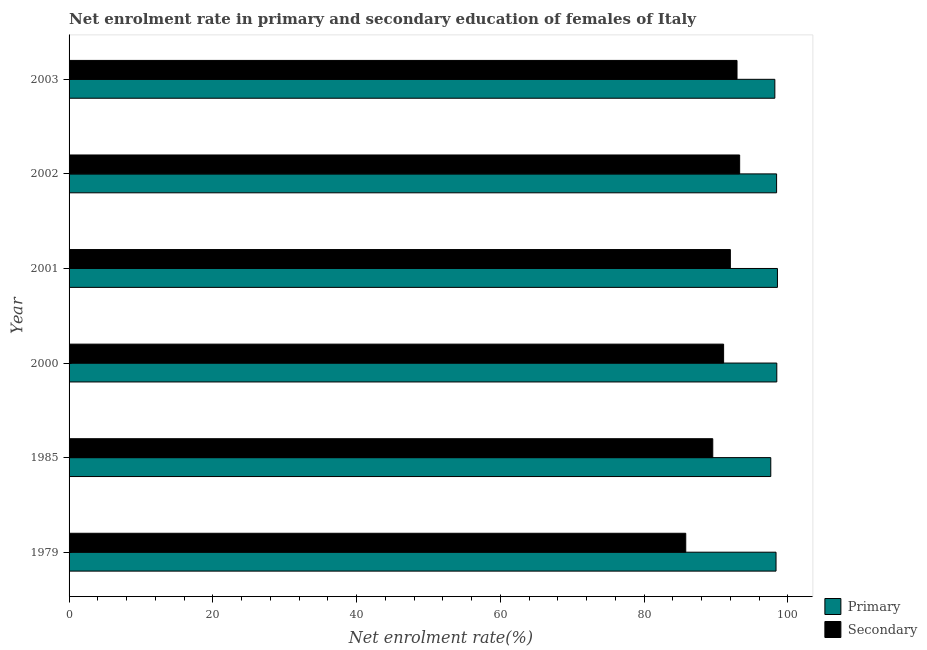How many groups of bars are there?
Your response must be concise. 6. Are the number of bars per tick equal to the number of legend labels?
Provide a succinct answer. Yes. Are the number of bars on each tick of the Y-axis equal?
Make the answer very short. Yes. What is the label of the 6th group of bars from the top?
Offer a terse response. 1979. What is the enrollment rate in primary education in 2001?
Offer a very short reply. 98.56. Across all years, what is the maximum enrollment rate in secondary education?
Provide a succinct answer. 93.3. Across all years, what is the minimum enrollment rate in primary education?
Your answer should be compact. 97.63. What is the total enrollment rate in secondary education in the graph?
Your response must be concise. 544.66. What is the difference between the enrollment rate in secondary education in 1985 and that in 2000?
Your answer should be compact. -1.51. What is the difference between the enrollment rate in primary education in 2000 and the enrollment rate in secondary education in 2002?
Provide a short and direct response. 5.17. What is the average enrollment rate in secondary education per year?
Keep it short and to the point. 90.78. In the year 2001, what is the difference between the enrollment rate in secondary education and enrollment rate in primary education?
Your response must be concise. -6.55. What is the ratio of the enrollment rate in secondary education in 2001 to that in 2002?
Give a very brief answer. 0.99. What is the difference between the highest and the second highest enrollment rate in secondary education?
Your answer should be compact. 0.37. Is the sum of the enrollment rate in primary education in 2000 and 2003 greater than the maximum enrollment rate in secondary education across all years?
Keep it short and to the point. Yes. What does the 1st bar from the top in 2001 represents?
Offer a very short reply. Secondary. What does the 2nd bar from the bottom in 2001 represents?
Your answer should be very brief. Secondary. Are all the bars in the graph horizontal?
Provide a succinct answer. Yes. How many years are there in the graph?
Ensure brevity in your answer.  6. What is the difference between two consecutive major ticks on the X-axis?
Your answer should be very brief. 20. Where does the legend appear in the graph?
Your response must be concise. Bottom right. How are the legend labels stacked?
Give a very brief answer. Vertical. What is the title of the graph?
Provide a short and direct response. Net enrolment rate in primary and secondary education of females of Italy. Does "Current US$" appear as one of the legend labels in the graph?
Make the answer very short. No. What is the label or title of the X-axis?
Your answer should be very brief. Net enrolment rate(%). What is the Net enrolment rate(%) of Primary in 1979?
Provide a succinct answer. 98.36. What is the Net enrolment rate(%) in Secondary in 1979?
Your answer should be very brief. 85.8. What is the Net enrolment rate(%) in Primary in 1985?
Give a very brief answer. 97.63. What is the Net enrolment rate(%) in Secondary in 1985?
Your response must be concise. 89.56. What is the Net enrolment rate(%) in Primary in 2000?
Ensure brevity in your answer.  98.47. What is the Net enrolment rate(%) in Secondary in 2000?
Your answer should be compact. 91.07. What is the Net enrolment rate(%) of Primary in 2001?
Offer a very short reply. 98.56. What is the Net enrolment rate(%) in Secondary in 2001?
Offer a terse response. 92.01. What is the Net enrolment rate(%) of Primary in 2002?
Provide a short and direct response. 98.44. What is the Net enrolment rate(%) of Secondary in 2002?
Your response must be concise. 93.3. What is the Net enrolment rate(%) of Primary in 2003?
Offer a very short reply. 98.19. What is the Net enrolment rate(%) in Secondary in 2003?
Give a very brief answer. 92.93. Across all years, what is the maximum Net enrolment rate(%) in Primary?
Provide a short and direct response. 98.56. Across all years, what is the maximum Net enrolment rate(%) of Secondary?
Provide a short and direct response. 93.3. Across all years, what is the minimum Net enrolment rate(%) of Primary?
Make the answer very short. 97.63. Across all years, what is the minimum Net enrolment rate(%) in Secondary?
Keep it short and to the point. 85.8. What is the total Net enrolment rate(%) of Primary in the graph?
Your answer should be compact. 589.65. What is the total Net enrolment rate(%) in Secondary in the graph?
Offer a very short reply. 544.66. What is the difference between the Net enrolment rate(%) in Primary in 1979 and that in 1985?
Your answer should be compact. 0.73. What is the difference between the Net enrolment rate(%) in Secondary in 1979 and that in 1985?
Offer a terse response. -3.76. What is the difference between the Net enrolment rate(%) in Primary in 1979 and that in 2000?
Your answer should be very brief. -0.11. What is the difference between the Net enrolment rate(%) of Secondary in 1979 and that in 2000?
Offer a terse response. -5.27. What is the difference between the Net enrolment rate(%) of Primary in 1979 and that in 2001?
Offer a very short reply. -0.2. What is the difference between the Net enrolment rate(%) of Secondary in 1979 and that in 2001?
Provide a succinct answer. -6.21. What is the difference between the Net enrolment rate(%) in Primary in 1979 and that in 2002?
Offer a very short reply. -0.08. What is the difference between the Net enrolment rate(%) of Secondary in 1979 and that in 2002?
Make the answer very short. -7.5. What is the difference between the Net enrolment rate(%) of Primary in 1979 and that in 2003?
Keep it short and to the point. 0.17. What is the difference between the Net enrolment rate(%) in Secondary in 1979 and that in 2003?
Provide a short and direct response. -7.13. What is the difference between the Net enrolment rate(%) in Primary in 1985 and that in 2000?
Your answer should be very brief. -0.84. What is the difference between the Net enrolment rate(%) in Secondary in 1985 and that in 2000?
Give a very brief answer. -1.51. What is the difference between the Net enrolment rate(%) of Primary in 1985 and that in 2001?
Ensure brevity in your answer.  -0.93. What is the difference between the Net enrolment rate(%) of Secondary in 1985 and that in 2001?
Your response must be concise. -2.45. What is the difference between the Net enrolment rate(%) in Primary in 1985 and that in 2002?
Your response must be concise. -0.81. What is the difference between the Net enrolment rate(%) in Secondary in 1985 and that in 2002?
Your response must be concise. -3.74. What is the difference between the Net enrolment rate(%) of Primary in 1985 and that in 2003?
Your answer should be very brief. -0.56. What is the difference between the Net enrolment rate(%) of Secondary in 1985 and that in 2003?
Your answer should be very brief. -3.38. What is the difference between the Net enrolment rate(%) of Primary in 2000 and that in 2001?
Your answer should be compact. -0.09. What is the difference between the Net enrolment rate(%) of Secondary in 2000 and that in 2001?
Provide a short and direct response. -0.94. What is the difference between the Net enrolment rate(%) of Primary in 2000 and that in 2002?
Keep it short and to the point. 0.03. What is the difference between the Net enrolment rate(%) of Secondary in 2000 and that in 2002?
Ensure brevity in your answer.  -2.23. What is the difference between the Net enrolment rate(%) in Primary in 2000 and that in 2003?
Your response must be concise. 0.27. What is the difference between the Net enrolment rate(%) in Secondary in 2000 and that in 2003?
Provide a succinct answer. -1.87. What is the difference between the Net enrolment rate(%) of Primary in 2001 and that in 2002?
Offer a very short reply. 0.12. What is the difference between the Net enrolment rate(%) of Secondary in 2001 and that in 2002?
Ensure brevity in your answer.  -1.29. What is the difference between the Net enrolment rate(%) in Primary in 2001 and that in 2003?
Ensure brevity in your answer.  0.36. What is the difference between the Net enrolment rate(%) in Secondary in 2001 and that in 2003?
Give a very brief answer. -0.93. What is the difference between the Net enrolment rate(%) in Primary in 2002 and that in 2003?
Offer a very short reply. 0.24. What is the difference between the Net enrolment rate(%) in Secondary in 2002 and that in 2003?
Give a very brief answer. 0.37. What is the difference between the Net enrolment rate(%) of Primary in 1979 and the Net enrolment rate(%) of Secondary in 1985?
Give a very brief answer. 8.8. What is the difference between the Net enrolment rate(%) of Primary in 1979 and the Net enrolment rate(%) of Secondary in 2000?
Your response must be concise. 7.29. What is the difference between the Net enrolment rate(%) in Primary in 1979 and the Net enrolment rate(%) in Secondary in 2001?
Give a very brief answer. 6.36. What is the difference between the Net enrolment rate(%) of Primary in 1979 and the Net enrolment rate(%) of Secondary in 2002?
Your answer should be very brief. 5.06. What is the difference between the Net enrolment rate(%) in Primary in 1979 and the Net enrolment rate(%) in Secondary in 2003?
Provide a short and direct response. 5.43. What is the difference between the Net enrolment rate(%) in Primary in 1985 and the Net enrolment rate(%) in Secondary in 2000?
Offer a very short reply. 6.56. What is the difference between the Net enrolment rate(%) of Primary in 1985 and the Net enrolment rate(%) of Secondary in 2001?
Make the answer very short. 5.62. What is the difference between the Net enrolment rate(%) of Primary in 1985 and the Net enrolment rate(%) of Secondary in 2002?
Provide a short and direct response. 4.33. What is the difference between the Net enrolment rate(%) in Primary in 1985 and the Net enrolment rate(%) in Secondary in 2003?
Offer a very short reply. 4.7. What is the difference between the Net enrolment rate(%) in Primary in 2000 and the Net enrolment rate(%) in Secondary in 2001?
Keep it short and to the point. 6.46. What is the difference between the Net enrolment rate(%) in Primary in 2000 and the Net enrolment rate(%) in Secondary in 2002?
Provide a short and direct response. 5.17. What is the difference between the Net enrolment rate(%) of Primary in 2000 and the Net enrolment rate(%) of Secondary in 2003?
Ensure brevity in your answer.  5.54. What is the difference between the Net enrolment rate(%) of Primary in 2001 and the Net enrolment rate(%) of Secondary in 2002?
Your answer should be compact. 5.26. What is the difference between the Net enrolment rate(%) of Primary in 2001 and the Net enrolment rate(%) of Secondary in 2003?
Your response must be concise. 5.62. What is the difference between the Net enrolment rate(%) in Primary in 2002 and the Net enrolment rate(%) in Secondary in 2003?
Provide a short and direct response. 5.51. What is the average Net enrolment rate(%) of Primary per year?
Your answer should be very brief. 98.27. What is the average Net enrolment rate(%) of Secondary per year?
Keep it short and to the point. 90.78. In the year 1979, what is the difference between the Net enrolment rate(%) in Primary and Net enrolment rate(%) in Secondary?
Your response must be concise. 12.56. In the year 1985, what is the difference between the Net enrolment rate(%) in Primary and Net enrolment rate(%) in Secondary?
Keep it short and to the point. 8.07. In the year 2000, what is the difference between the Net enrolment rate(%) of Primary and Net enrolment rate(%) of Secondary?
Your answer should be compact. 7.4. In the year 2001, what is the difference between the Net enrolment rate(%) in Primary and Net enrolment rate(%) in Secondary?
Make the answer very short. 6.55. In the year 2002, what is the difference between the Net enrolment rate(%) of Primary and Net enrolment rate(%) of Secondary?
Ensure brevity in your answer.  5.14. In the year 2003, what is the difference between the Net enrolment rate(%) of Primary and Net enrolment rate(%) of Secondary?
Your response must be concise. 5.26. What is the ratio of the Net enrolment rate(%) in Primary in 1979 to that in 1985?
Ensure brevity in your answer.  1.01. What is the ratio of the Net enrolment rate(%) in Secondary in 1979 to that in 1985?
Offer a terse response. 0.96. What is the ratio of the Net enrolment rate(%) of Secondary in 1979 to that in 2000?
Your answer should be compact. 0.94. What is the ratio of the Net enrolment rate(%) in Secondary in 1979 to that in 2001?
Make the answer very short. 0.93. What is the ratio of the Net enrolment rate(%) of Secondary in 1979 to that in 2002?
Provide a succinct answer. 0.92. What is the ratio of the Net enrolment rate(%) in Secondary in 1979 to that in 2003?
Your answer should be compact. 0.92. What is the ratio of the Net enrolment rate(%) in Secondary in 1985 to that in 2000?
Your answer should be compact. 0.98. What is the ratio of the Net enrolment rate(%) of Primary in 1985 to that in 2001?
Give a very brief answer. 0.99. What is the ratio of the Net enrolment rate(%) in Secondary in 1985 to that in 2001?
Make the answer very short. 0.97. What is the ratio of the Net enrolment rate(%) of Primary in 1985 to that in 2002?
Offer a very short reply. 0.99. What is the ratio of the Net enrolment rate(%) in Secondary in 1985 to that in 2002?
Offer a terse response. 0.96. What is the ratio of the Net enrolment rate(%) of Secondary in 1985 to that in 2003?
Keep it short and to the point. 0.96. What is the ratio of the Net enrolment rate(%) of Primary in 2000 to that in 2001?
Keep it short and to the point. 1. What is the ratio of the Net enrolment rate(%) in Secondary in 2000 to that in 2001?
Your answer should be very brief. 0.99. What is the ratio of the Net enrolment rate(%) of Primary in 2000 to that in 2002?
Keep it short and to the point. 1. What is the ratio of the Net enrolment rate(%) of Secondary in 2000 to that in 2002?
Your answer should be compact. 0.98. What is the ratio of the Net enrolment rate(%) of Secondary in 2000 to that in 2003?
Give a very brief answer. 0.98. What is the ratio of the Net enrolment rate(%) in Primary in 2001 to that in 2002?
Your answer should be compact. 1. What is the ratio of the Net enrolment rate(%) in Secondary in 2001 to that in 2002?
Give a very brief answer. 0.99. What is the ratio of the Net enrolment rate(%) in Primary in 2001 to that in 2003?
Ensure brevity in your answer.  1. What is the ratio of the Net enrolment rate(%) of Primary in 2002 to that in 2003?
Keep it short and to the point. 1. What is the ratio of the Net enrolment rate(%) of Secondary in 2002 to that in 2003?
Provide a succinct answer. 1. What is the difference between the highest and the second highest Net enrolment rate(%) in Primary?
Offer a terse response. 0.09. What is the difference between the highest and the second highest Net enrolment rate(%) in Secondary?
Your answer should be very brief. 0.37. What is the difference between the highest and the lowest Net enrolment rate(%) in Primary?
Give a very brief answer. 0.93. What is the difference between the highest and the lowest Net enrolment rate(%) in Secondary?
Your response must be concise. 7.5. 